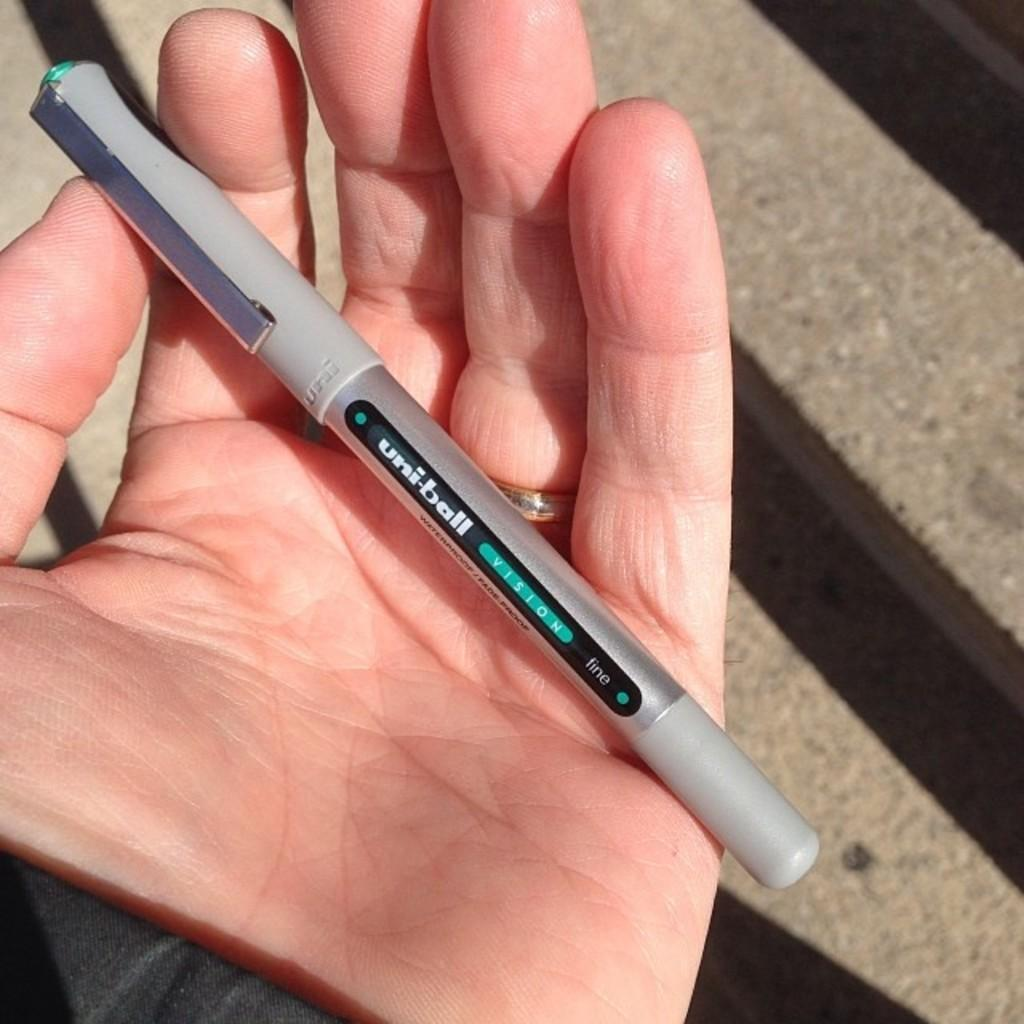What is the main subject of the image? A human hand is present in the image. What is the hand holding? The hand is holding a pen. What type of meal is being prepared by the hand in the image? There is no meal preparation visible in the image; the hand is holding a pen. What emotion is the hand expressing in the image? The image does not depict emotions, as it only shows a hand holding a pen. 